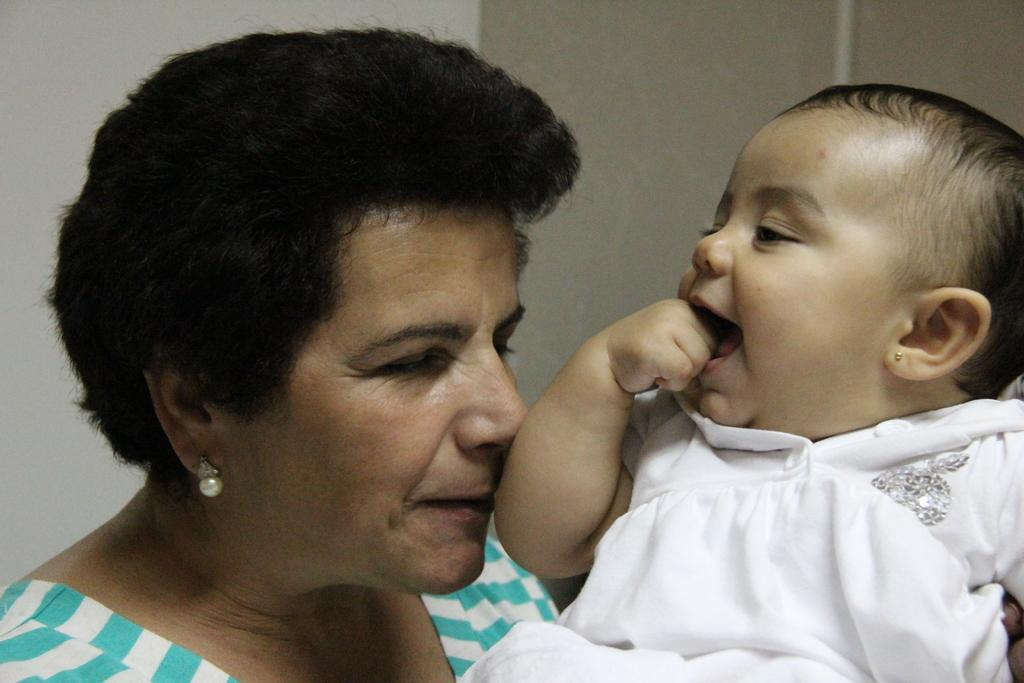Who is present in the image? There is a woman and a baby in the image. What is the baby wearing? The baby is wearing a white dress. What is the woman wearing? The woman is wearing a top with blue and white colors. What type of appliance can be seen in the background of the image? There is no appliance present in the image. Is there a patch on the baby's dress? The facts do not mention any patch on the baby's dress, so we cannot determine its presence from the image. 